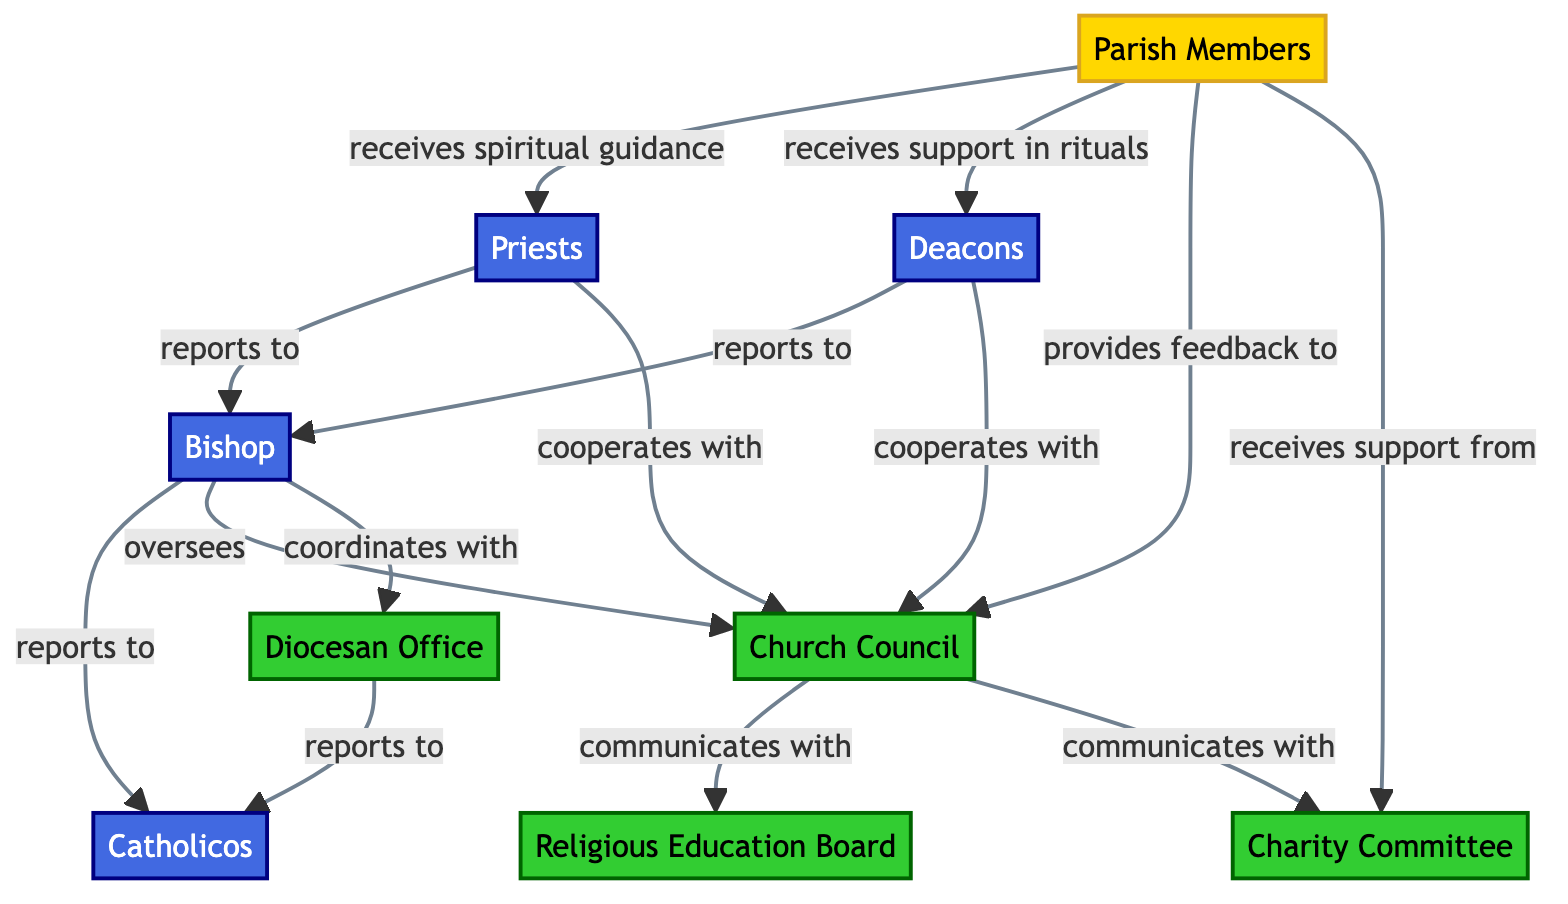What are the nodes in the diagram? The diagram consists of 9 nodes: Parish Members, Priests, Deacons, Bishop, Church Council, Diocesan Office, Catholicos, Religious Education Board, and Charity Committee.
Answer: 9 nodes Who cooperates with the Church Council? Both Priests and Deacons cooperate with the Church Council as indicated by the arrows pointing from those nodes to the Church Council.
Answer: Priests and Deacons What is the relationship between Bishops and the Catholicos? Bishops report to the Catholicos, as shown by the directed link from the Bishops to the Catholicos node in the diagram.
Answer: reports to How many links are there in the diagram? By counting all the connections (represented as links) between the nodes, there are a total of 13 links.
Answer: 13 links Which group receives support in rituals? The Deacons group receives support in rituals based on the flow from the Parish Members to the Deacons indicating that relationship.
Answer: Deacons Who provides feedback to the Church Council? The Parish Members provide feedback to the Church Council, as indicated by the directed flow from the Parish Members to the Church Council.
Answer: Parish Members What administrative body communicates with the Religious Education Board? The Church Council communicates with the Religious Education Board, as shown by the connection from the Church Council to the Religious Education Board in the diagram.
Answer: Church Council What is the primary role of the Bishop in relation to the Church Council? The primary role of the Bishop is to oversee the Church Council, which is evident from the link that flows from the Bishop to the Church Council indicating oversight.
Answer: oversees How many different types of nodes are there in the diagram? There are three types of nodes: Group, Cleric, and Administrative, as described in the classifications of the nodes.
Answer: 3 types 